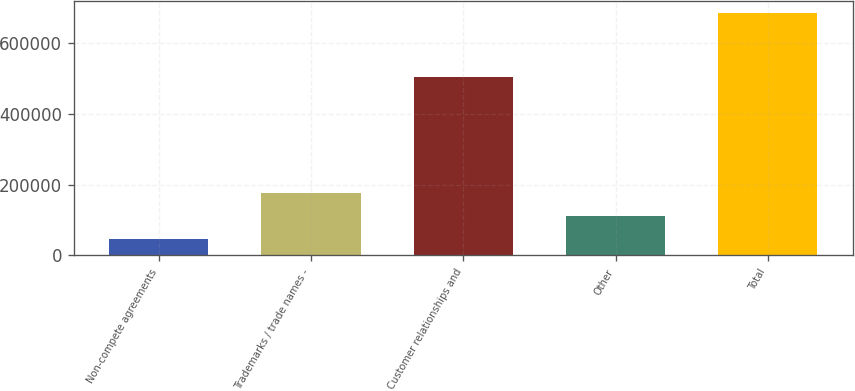Convert chart to OTSL. <chart><loc_0><loc_0><loc_500><loc_500><bar_chart><fcel>Non-compete agreements<fcel>Trademarks / trade names -<fcel>Customer relationships and<fcel>Other<fcel>Total<nl><fcel>47351<fcel>175034<fcel>504387<fcel>111192<fcel>685764<nl></chart> 